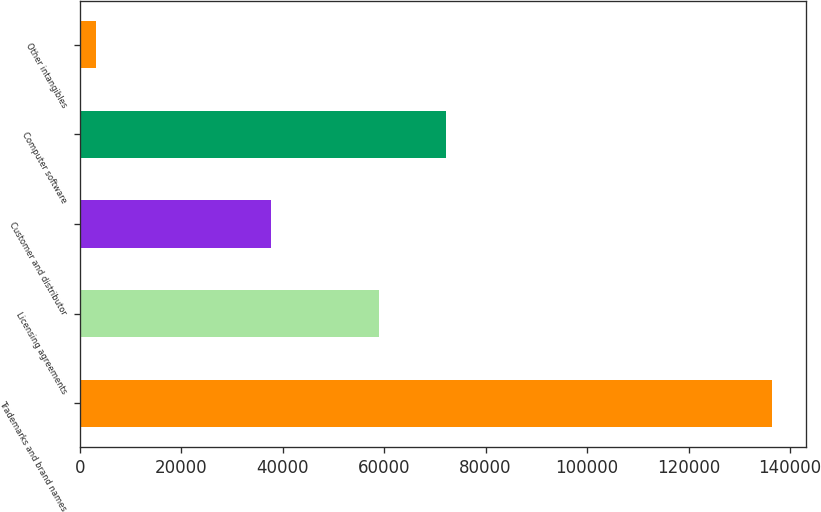Convert chart to OTSL. <chart><loc_0><loc_0><loc_500><loc_500><bar_chart><fcel>Trademarks and brand names<fcel>Licensing agreements<fcel>Customer and distributor<fcel>Computer software<fcel>Other intangibles<nl><fcel>136379<fcel>58901<fcel>37654<fcel>72210.8<fcel>3281<nl></chart> 